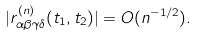<formula> <loc_0><loc_0><loc_500><loc_500>| r _ { \alpha \beta \gamma \delta } ^ { ( n ) } ( t _ { 1 } , t _ { 2 } ) | = O ( n ^ { - 1 / 2 } ) .</formula> 